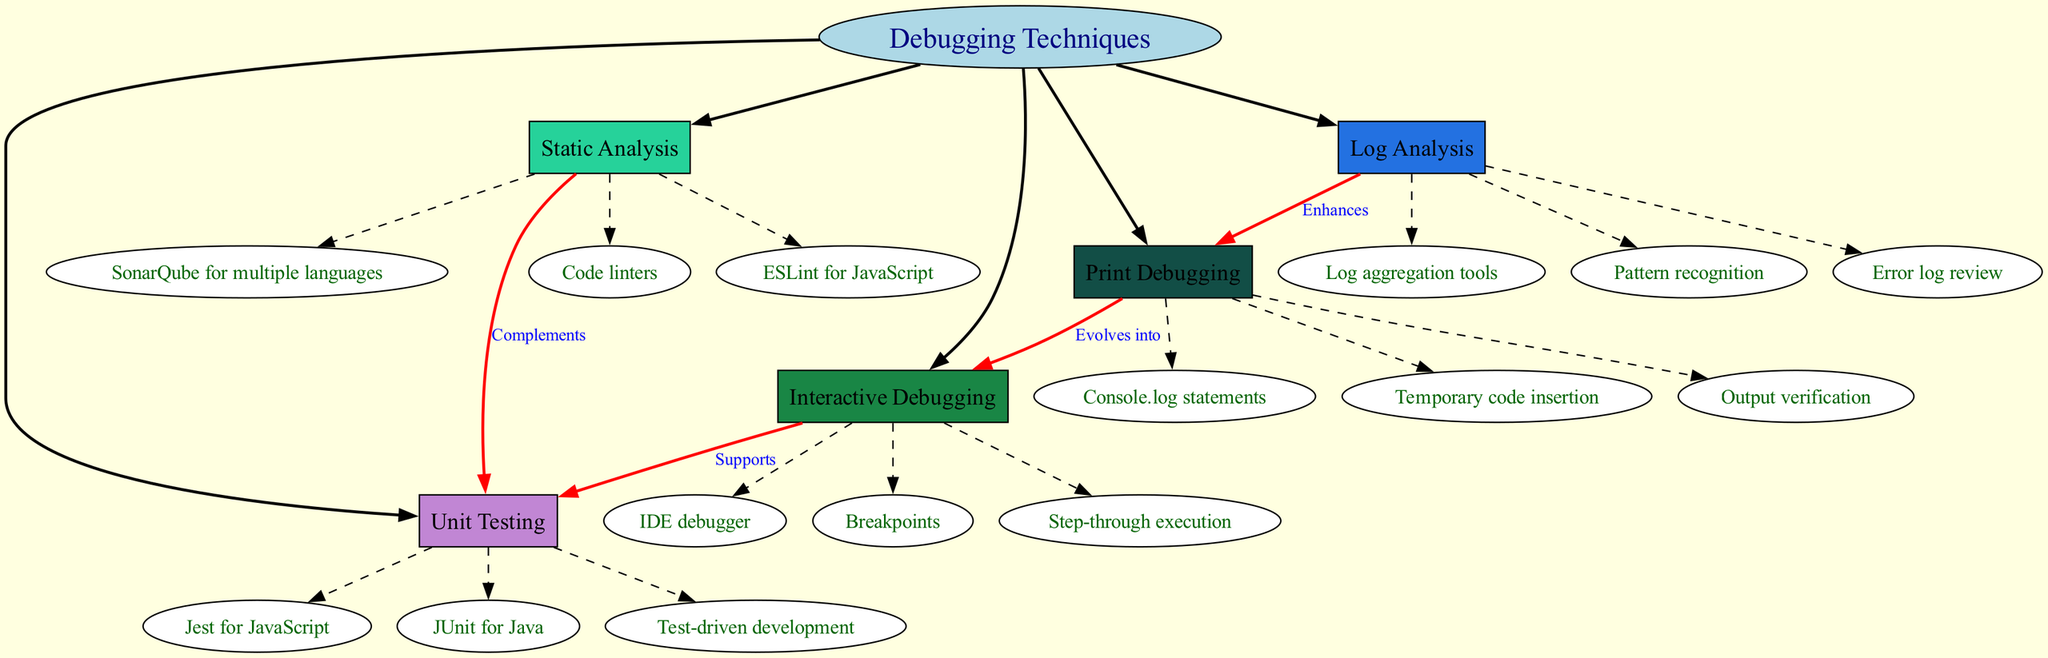What is the central topic of the diagram? The diagram clearly identifies the central topic, which is the first node labeled "Debugging Techniques." It serves as the primary focus of the concept map.
Answer: Debugging Techniques How many main branches are there? Upon examining the diagram, there are five distinct main branches connected to the central topic. Each branch represents a different debugging technique.
Answer: 5 What does Print Debugging evolve into? The relationship represented by an edge labeled "Evolves into" connects the Print Debugging node to the Interactive Debugging node. This indicates that Print Debugging is a precursor or an earlier method leading to Interactive Debugging.
Answer: Interactive Debugging Which debugging technique supports Unit Testing? The edge labeled "Supports" connects the Interactive Debugging node to the Unit Testing node, indicating that Interactive Debugging provides assistance or reinforcement to the Unit Testing process.
Answer: Interactive Debugging Name one tool used for Static Analysis. Looking at the subtopics listed under the Static Analysis branch, one of the tools explicitly mentioned is "ESLint for JavaScript," which is commonly used to analyze and enforce coding standards.
Answer: ESLint for JavaScript What relationship does Log Analysis have with Print Debugging? The edge labeled "Enhances" indicates that Log Analysis contributes to or improves the Print Debugging technique. This signifies that insights gained from Log Analysis can be beneficial to Print Debugging efforts.
Answer: Enhances Which debugging technique complements Unit Testing? The relationship portrayed by the edge labeled "Complements" links Static Analysis to Unit Testing, suggesting that Static Analysis aids or adds value to the Unit Testing methodology.
Answer: Static Analysis How many subtopics are listed under Unit Testing? By examining the Unit Testing branch, we find a total of three subtopics specified. Each of these contributes to understanding and implementing Unit Testing in different programming languages.
Answer: 3 